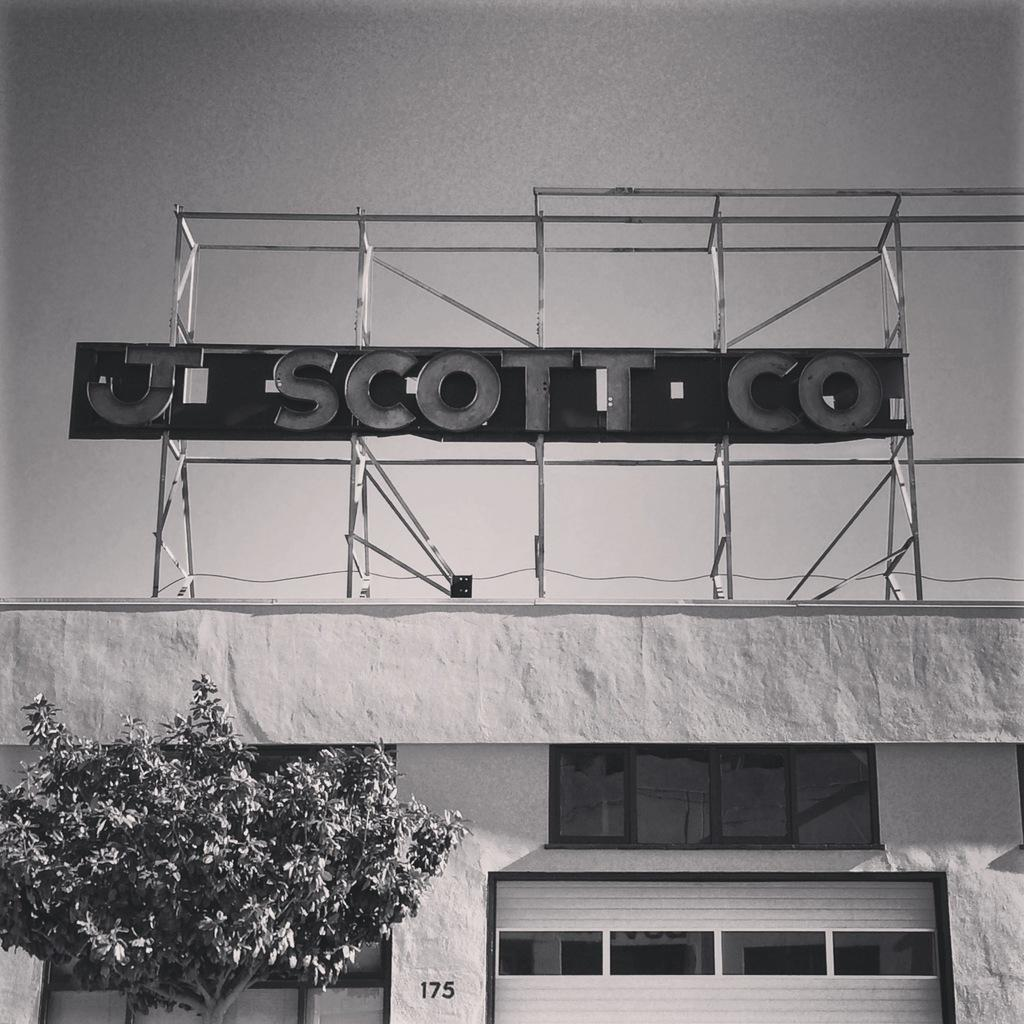<image>
Render a clear and concise summary of the photo. A sign board for teh J Scott Co above a building with a garage door. 